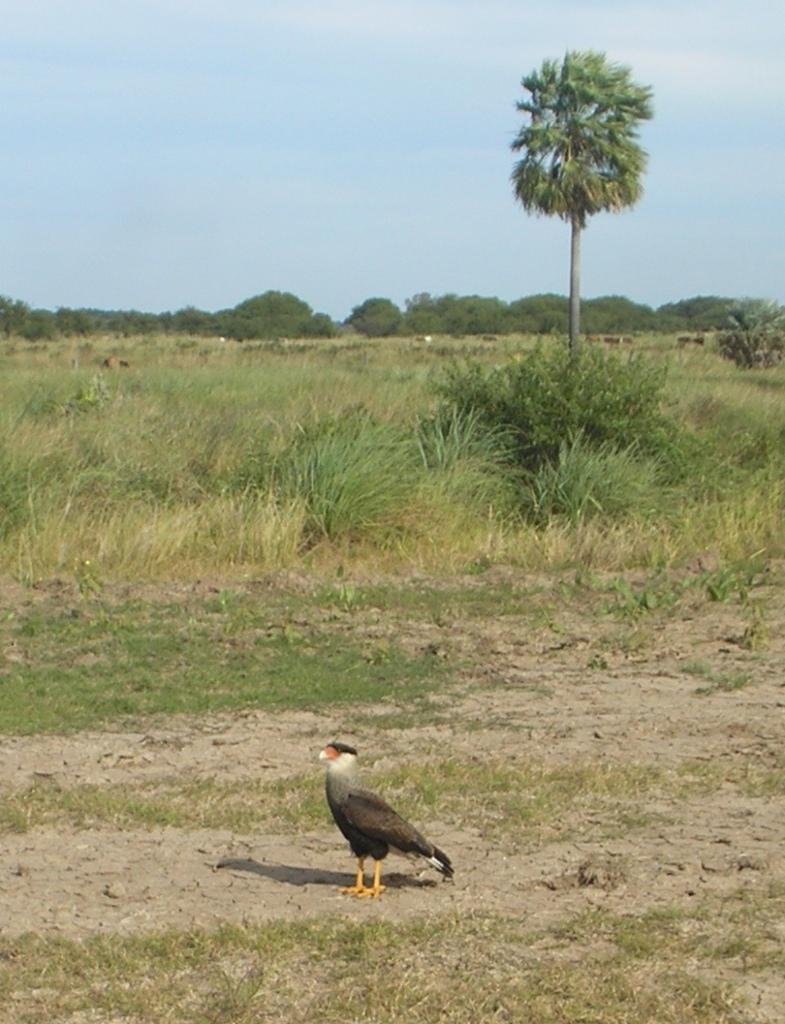What is the main subject in the center of the image? There is a bird in the center of the image. What type of natural environment is visible in the background of the image? There is grass, trees, and the sky visible in the background of the image. What color is the pencil that the bird is holding in the image? There is no pencil present in the image, and the bird is not holding any object. 